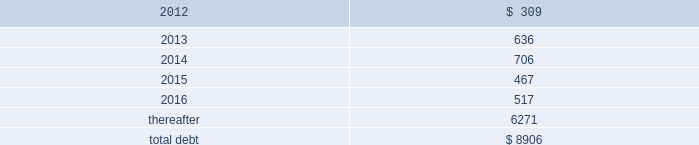Debt maturities 2013 the table presents aggregate debt maturities as of december 31 , 2011 , excluding market value adjustments : millions .
As of both december 31 , 2011 and december 31 , 2010 , we have reclassified as long-term debt approximately $ 100 million of debt due within one year that we intend to refinance .
This reclassification reflects our ability and intent to refinance any short-term borrowings and certain current maturities of long- term debt on a long-term basis .
Mortgaged properties 2013 equipment with a carrying value of approximately $ 2.9 billion and $ 3.2 billion at december 31 , 2011 and 2010 , respectively , served as collateral for capital leases and other types of equipment obligations in accordance with the secured financing arrangements utilized to acquire such railroad equipment .
As a result of the merger of missouri pacific railroad company ( mprr ) with and into uprr on january 1 , 1997 , and pursuant to the underlying indentures for the mprr mortgage bonds , uprr must maintain the same value of assets after the merger in order to comply with the security requirements of the mortgage bonds .
As of the merger date , the value of the mprr assets that secured the mortgage bonds was approximately $ 6.0 billion .
In accordance with the terms of the indentures , this collateral value must be maintained during the entire term of the mortgage bonds irrespective of the outstanding balance of such bonds .
Credit facilities 2013 during the second quarter of 2011 , we replaced our $ 1.9 billion revolving credit facility , which was scheduled to expire in april 2012 , with a new $ 1.8 billion facility that expires in may 2015 ( the facility ) .
The facility is based on substantially similar terms as those in the previous credit facility .
On december 31 , 2011 , we had $ 1.8 billion of credit available under the facility , which is designated for general corporate purposes and supports the issuance of commercial paper .
We did not draw on either facility during 2011 .
Commitment fees and interest rates payable under the facility are similar to fees and rates available to comparably rated , investment-grade borrowers .
The facility allows for borrowings at floating rates based on london interbank offered rates , plus a spread , depending upon our senior unsecured debt ratings .
The facility requires the corporation to maintain a debt-to-net-worth coverage ratio as a condition to making a borrowing .
At december 31 , 2011 , and december 31 , 2010 ( and at all times during the year ) , we were in compliance with this covenant .
The definition of debt used for purposes of calculating the debt-to-net-worth coverage ratio includes , among other things , certain credit arrangements , capital leases , guarantees and unfunded and vested pension benefits under title iv of erisa .
At december 31 , 2011 , the debt-to-net-worth coverage ratio allowed us to carry up to $ 37.2 billion of debt ( as defined in the facility ) , and we had $ 9.5 billion of debt ( as defined in the facility ) outstanding at that date .
Under our current capital plans , we expect to continue to satisfy the debt-to-net-worth coverage ratio ; however , many factors beyond our reasonable control ( including the risk factors in item 1a of this report ) could affect our ability to comply with this provision in the future .
The facility does not include any other financial restrictions , credit rating triggers ( other than rating-dependent pricing ) , or any other provision that could require us to post collateral .
The facility also includes a $ 75 million cross-default provision and a change-of-control provision .
During 2011 , we did not issue or repay any commercial paper and , at december 31 , 2011 , we had no commercial paper outstanding .
Outstanding commercial paper balances are supported by our revolving credit facility but do not reduce the amount of borrowings available under the facility .
Dividend restrictions 2013 our revolving credit facility includes a debt-to-net worth covenant ( discussed in the credit facilities section above ) that , under certain circumstances , restricts the payment of cash .
What percent of total aggregate debt maturities as of december 31 , 2011 are due in 2013? 
Computations: (636 / 8906)
Answer: 0.07141. 